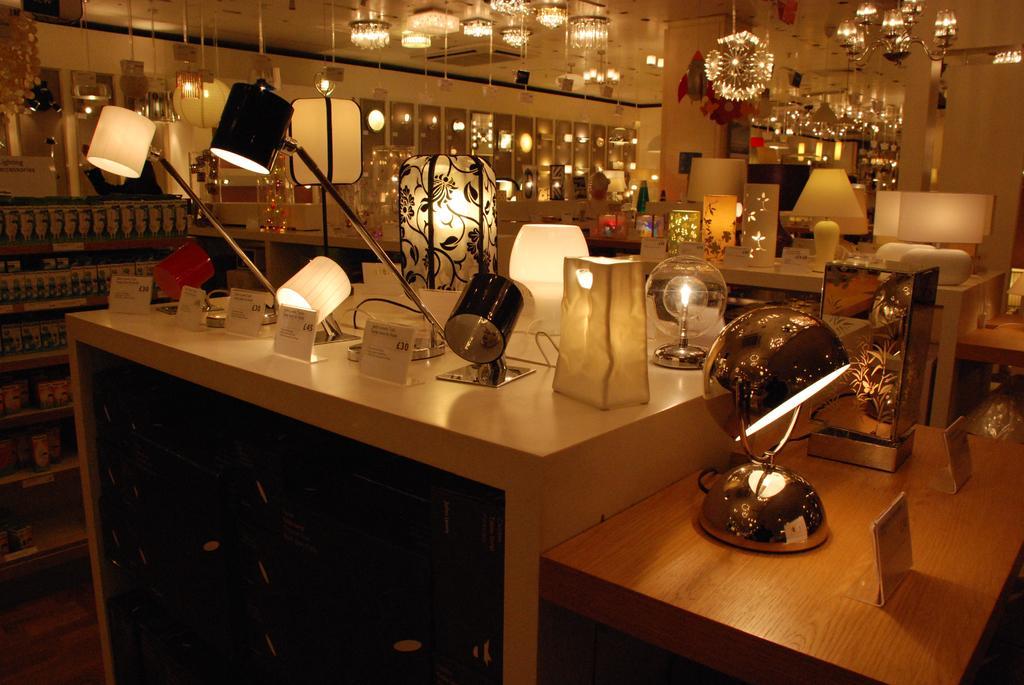In one or two sentences, can you explain what this image depicts? There are some table lamps are present on the table as we can see the middle of this image, and there is a wall in the background. We can see there are some chandeliers at the top of this image. 